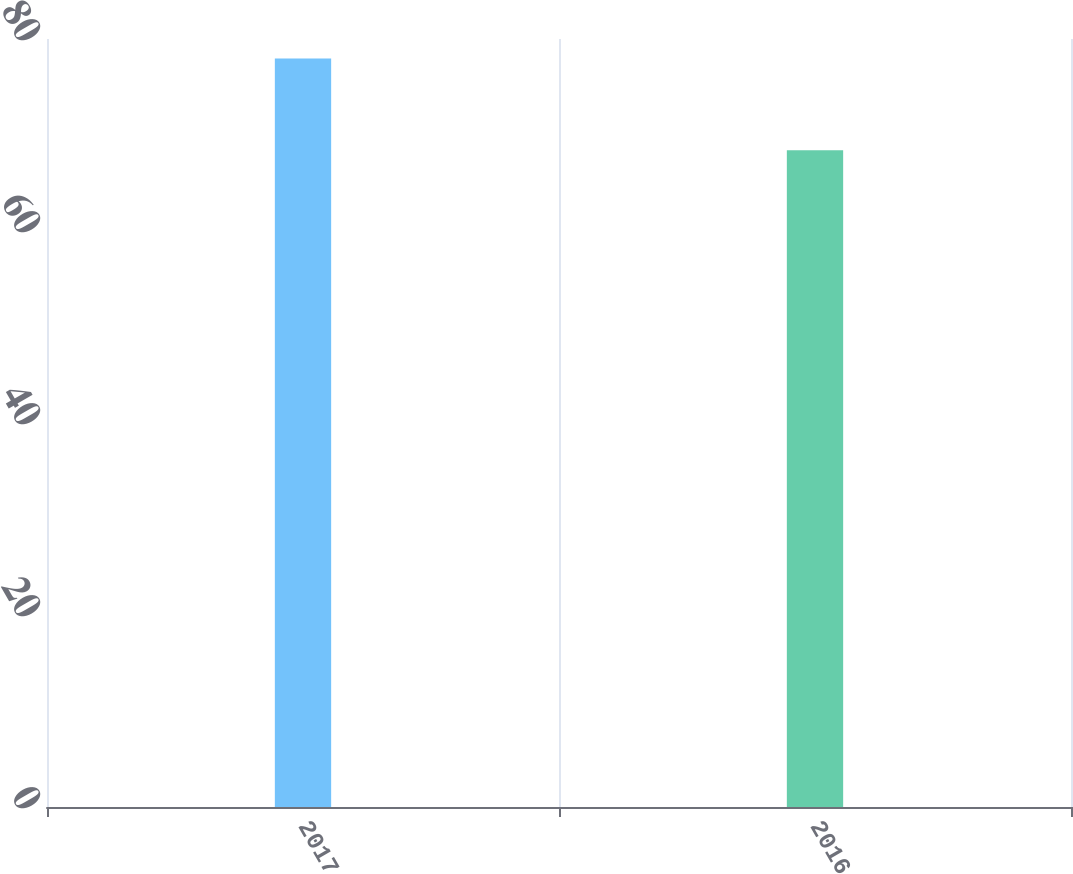<chart> <loc_0><loc_0><loc_500><loc_500><bar_chart><fcel>2017<fcel>2016<nl><fcel>77.97<fcel>68.42<nl></chart> 